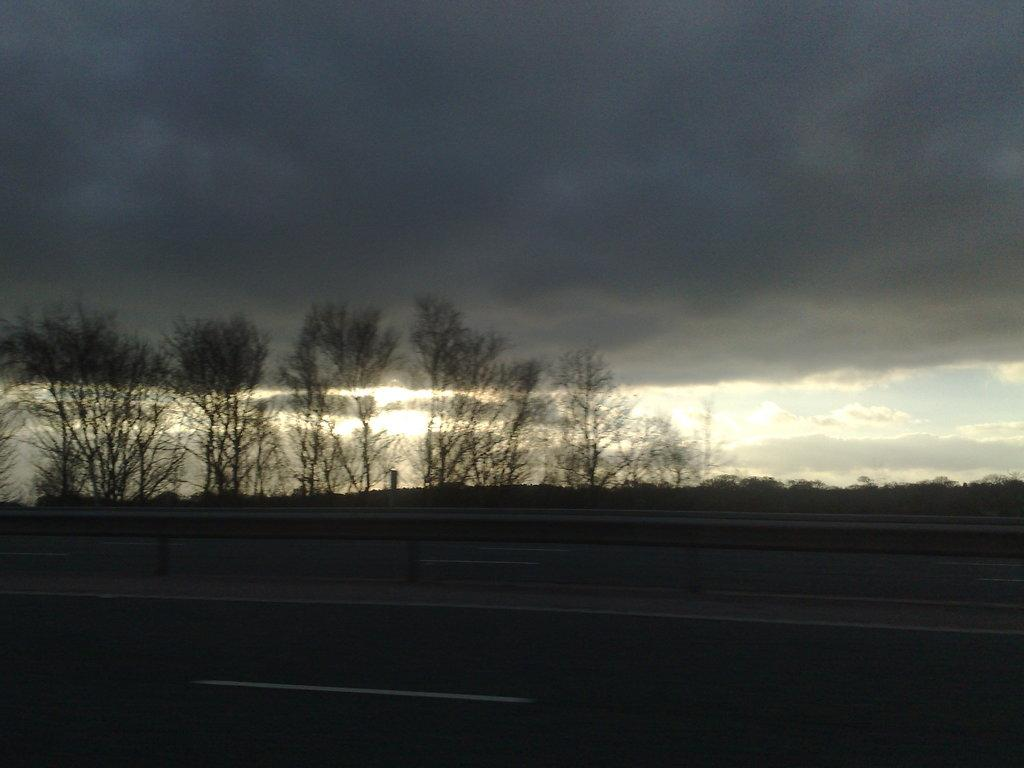What is located in the foreground of the image? There is a road and a railing in the foreground of the image. What can be seen in the background of the image? There are trees and the sky visible in the background of the image. What is the condition of the sky in the image? The sky is visible in the background of the image, and there are clouds present. What grade does the sweater receive in the image? There is no sweater present in the image, so it cannot receive a grade. How many baskets are hanging from the trees in the image? There are no baskets hanging from the trees in the image; only trees and the sky are visible. 